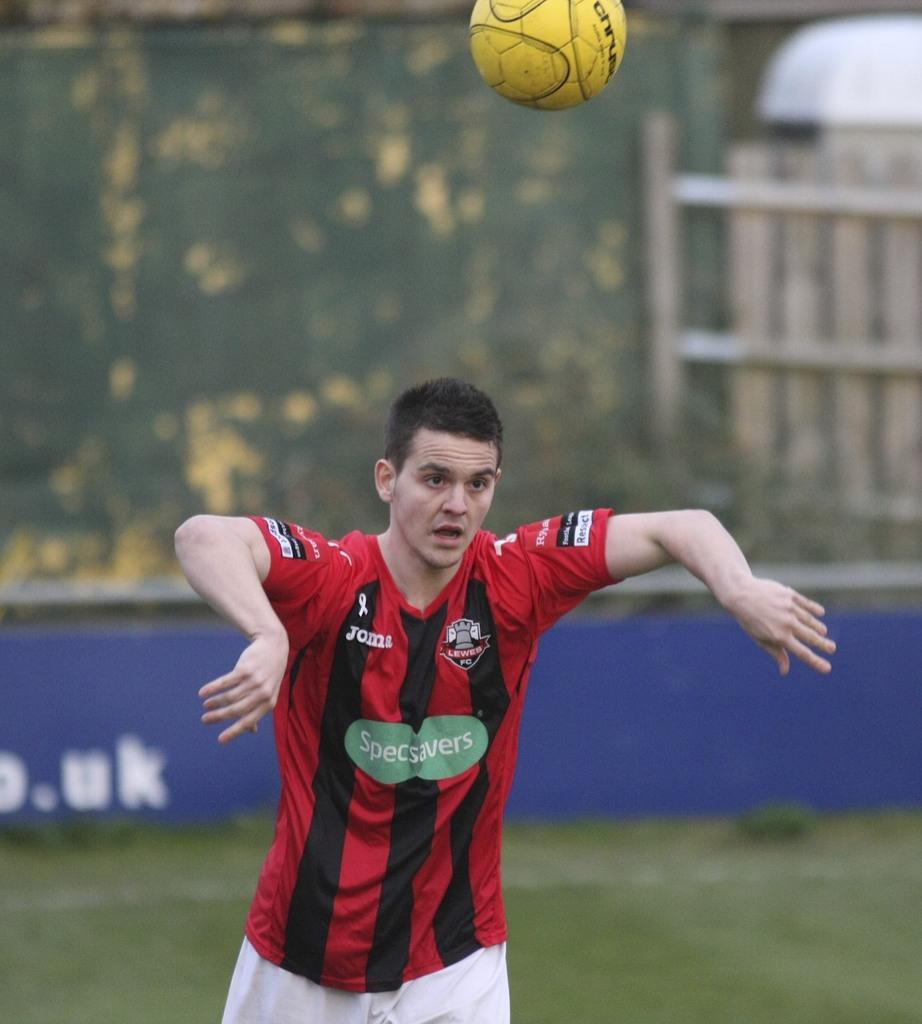<image>
Give a short and clear explanation of the subsequent image. A soccer player through the ball with a shirt that says Specsavers. 